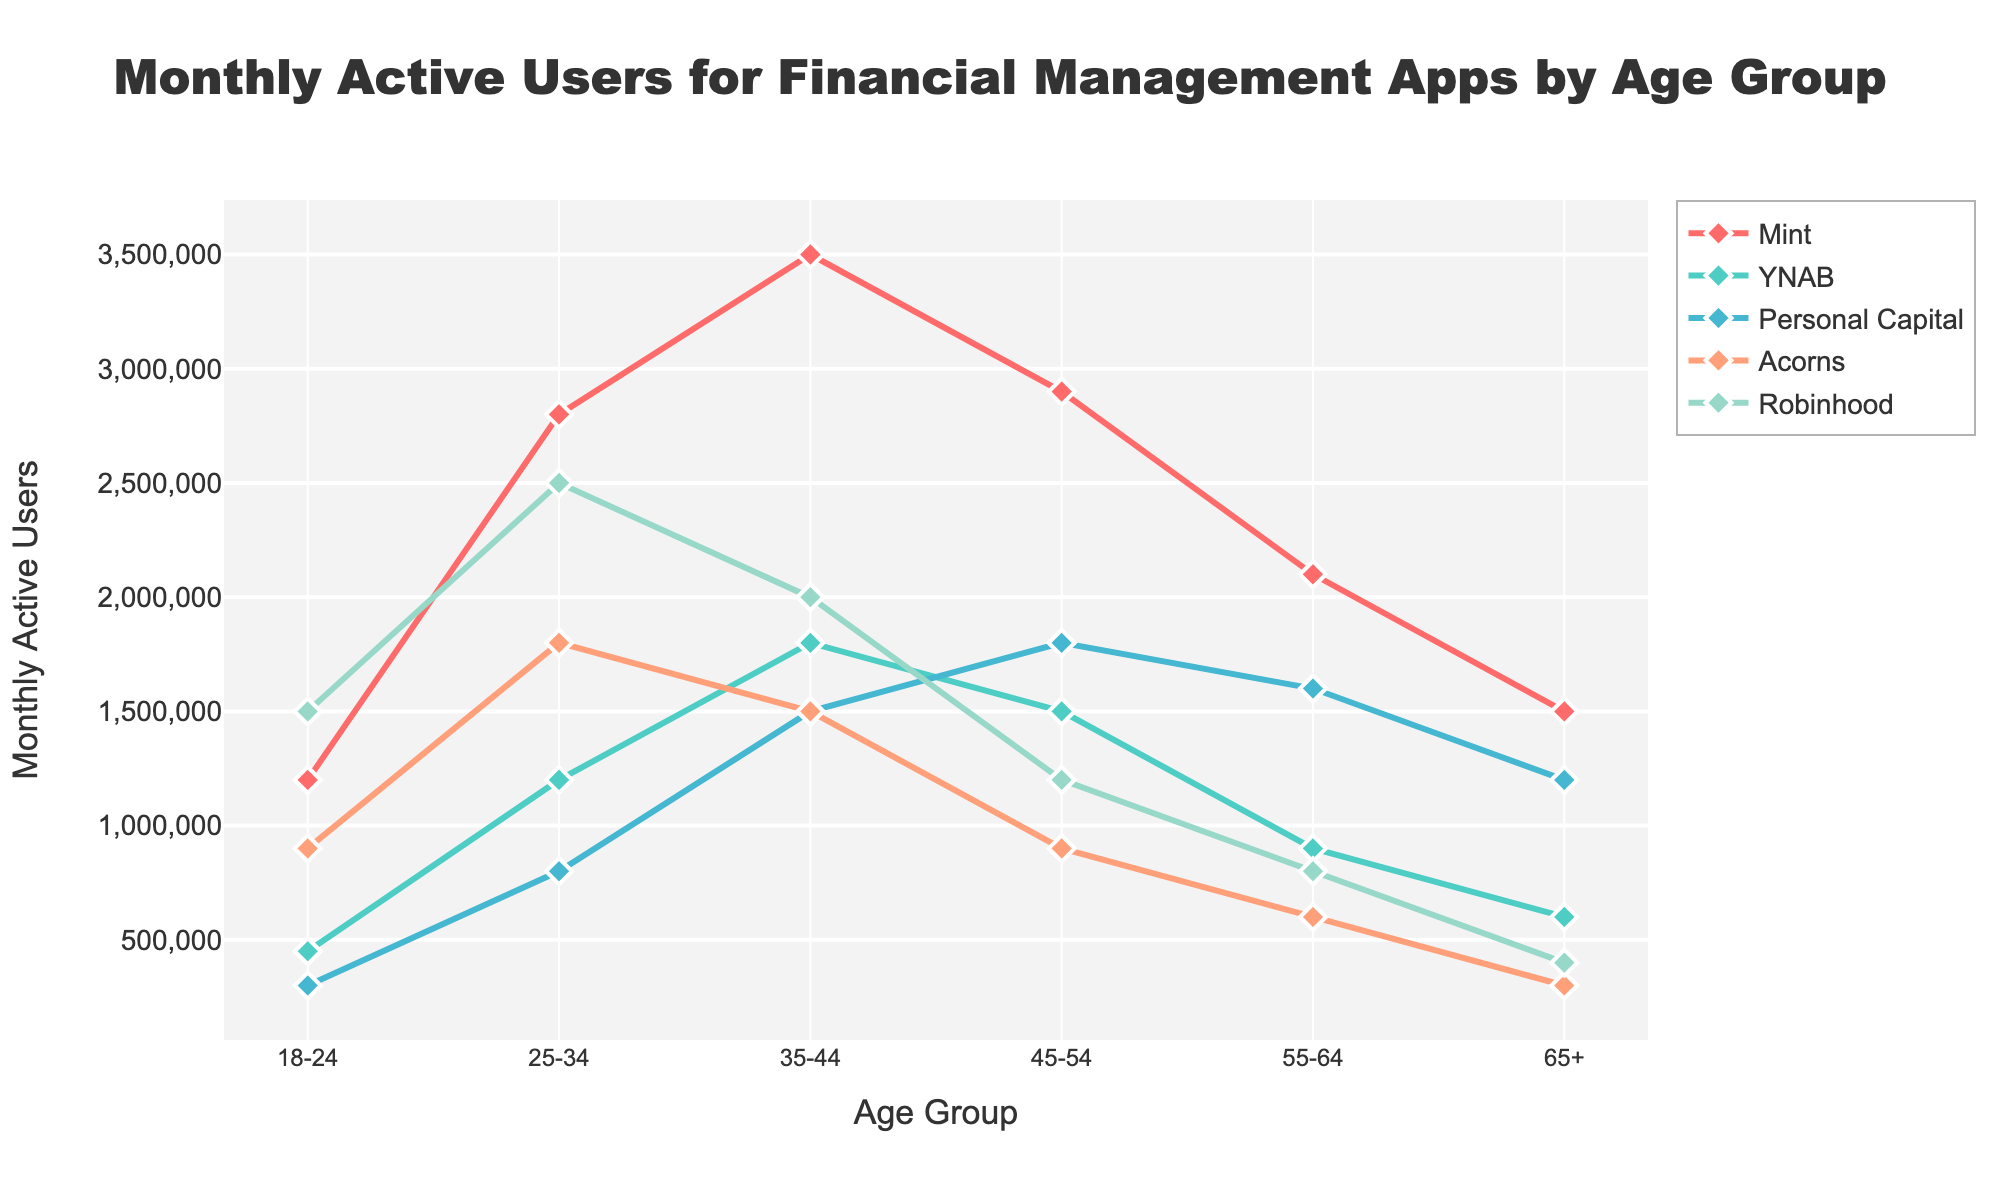What's the most popular app among users aged 25-34? The figure shows the line and markers for each app segmented by age groups. For the 25-34 age group, Robinhood has the highest position on the y-axis among all other apps.
Answer: Robinhood What's the difference in Monthly Active Users between Mint and YNAB for the 18-24 age group? For the 18-24 age group, the figure indicates Mint has 1,200,000 users, and YNAB has 450,000 users. The difference is 1,200,000 - 450,000.
Answer: 750,000 Which app shows a consistent decrease in users as age increases? By observing the downward slopes, Robinhood displays a clear trend where the number of users consistently decreases from the 18-24 age group to the 65+ age group.
Answer: Robinhood What is the total number of Monthly Active Users for Personal Capital across all age groups? Adding the values shown for Personal Capital: 300,000 (18-24) + 800,000 (25-34) + 1,500,000 (35-44) + 1,800,000 (45-54) + 1,600,000 (55-64) + 1,200,000 (65+). The total sum is 7,200,000.
Answer: 7,200,000 Which age group represents the highest number of Monthly Active Users for Acorns? The highest point on the y-axis corresponding to Acorns is for the 25-34 age group.
Answer: 25-34 What's the average number of Monthly Active Users for YNAB across all age groups? Summing the values for YNAB: 450,000 (18-24) + 1,200,000 (25-34) + 1,800,000 (35-44) + 1,500,000 (45-54) + 900,000 (55-64) + 600,000 (65+), giving a total of 6,450,000. The average is obtained by dividing by the number of age groups, 6: 6,450,000/6.
Answer: 1,075,000 For users aged 35-44, which app ranks second in popularity? For the 35-44 age group, observing the heights, Mint is at 3,500,000 (highest), and YNAB at 1,800,000 (second highest).
Answer: YNAB What is the percentage increase in the number of Monthly Active Users for Robinhood from age group 18-24 to 25-34? Robinhood has 1,500,000 users for 18-24 and 2,500,000 for 25-34. The increase is (2,500,000 - 1,500,000) / 1,500,000 * 100%.
Answer: 66.67% Which app has the lowest number of Monthly Active Users for the 65+ age group? For the 65+ age group, observing the plot, Acorns has the lowest number of users at 300,000.
Answer: Acorns 